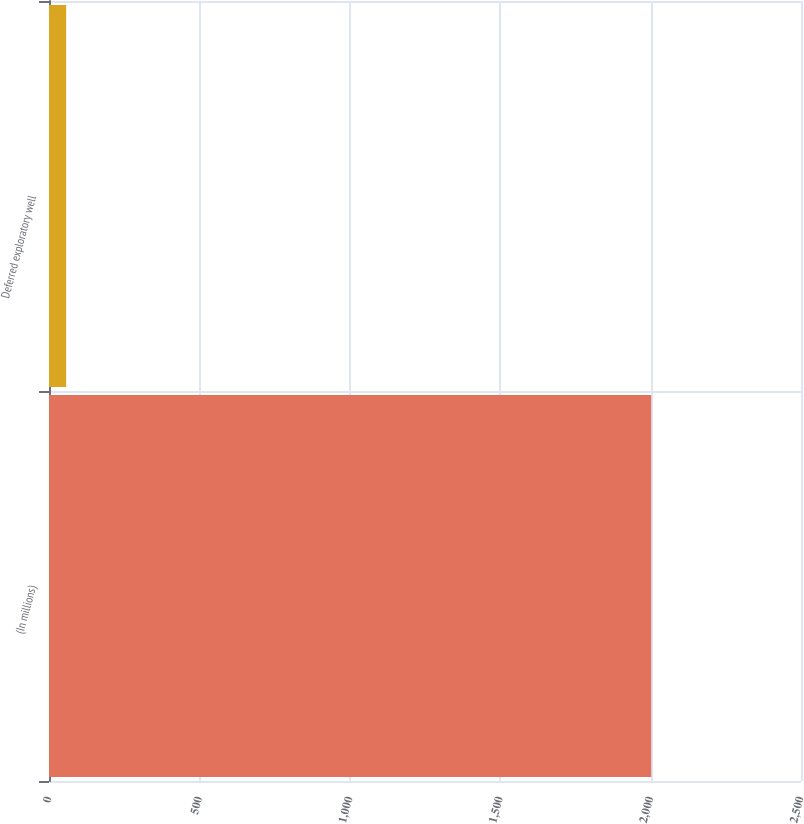Convert chart to OTSL. <chart><loc_0><loc_0><loc_500><loc_500><bar_chart><fcel>(In millions)<fcel>Deferred exploratory well<nl><fcel>2002<fcel>57<nl></chart> 